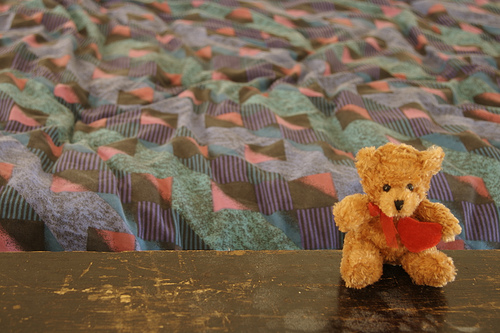<image>Who flew that ship? I don't know who flew the ship as there is no ship in the image. It can be seen that there's no one. Who flew that ship? It is unknown who flew that ship. There is no evidence of anyone flying the ship in the image. 